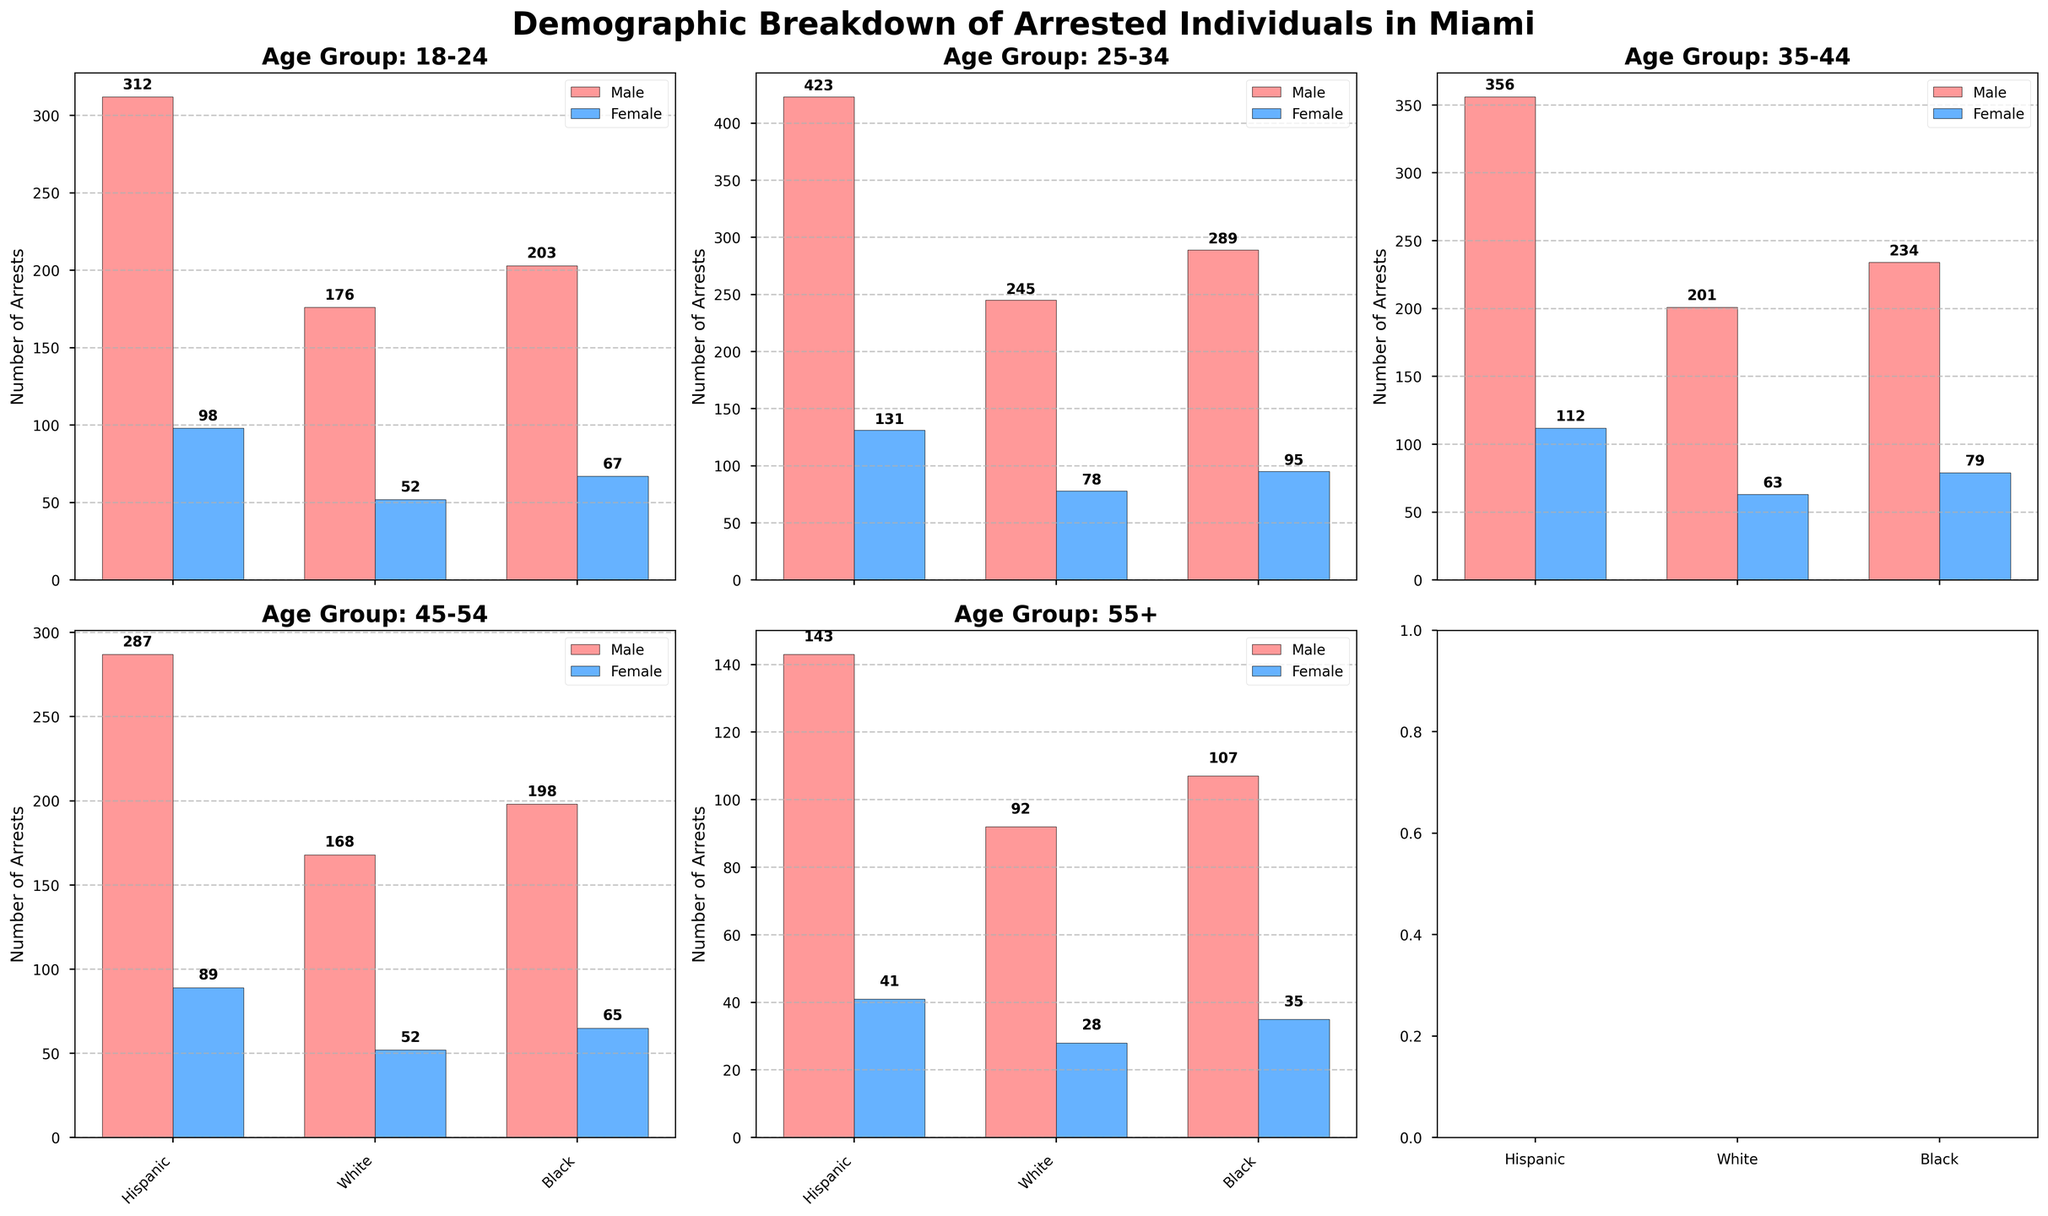What's the title of the figure? The title is usually located at the top of the figure and summarizes the main topic. Here, the title "Demographic Breakdown of Arrested Individuals in Miami" directly tells us what the figure is about.
Answer: Demographic Breakdown of Arrested Individuals in Miami How many age groups are presented in the figure? The number of subplots corresponds to the number of age groups, each with its own title indicating the age range. Counting the unique age group titles, we find five age groups.
Answer: 5 Which age group has the highest number of male arrests for Hispanic individuals? By examining the bars for male Hispanic arrests across all age group subplots, we observe that the '25-34' age group has the tallest bar, indicating the highest value.
Answer: 25-34 In the '45-54' age group, which gender has higher arrests for Black individuals? The heights of the bars in the '45-54' subplot for Black individuals show that males have taller bars compared to females.
Answer: Male Compare the number of arrests between Hispanic females and Black females in the '35-44' age group. Which is higher and by how much? Looking at the '35-44' subplot, the bar for Hispanic females is 112 and for Black females is 79. The difference is found by subtracting 79 from 112.
Answer: Hispanic, by 33 Identify the ethnic group with the lowest number of arrests in the '18-24' age group for both genders combined. Adding the arrests for both genders in each ethnic group in '18-24', the totals are: Hispanic (312 + 98 = 410), White (176 + 52 = 228), Black (203 + 67 = 270). Thus, White has the lowest combined arrests.
Answer: White For the age group '55+', which ethnic group has the greater gender gap in arrests, and what is the difference? For '55+', calculate the gender difference for each ethnic group: Hispanic (143 - 41 = 102), White (92 - 28 = 64), Black (107 - 35 = 72). Hispanic has the largest gender difference.
Answer: Hispanic, 102 Summarize the trend of male arrests across all age groups for White individuals. Observing the white male bars across each subplot, the counts start high at '18-24' with 176, increase to 245 in '25-34', then slightly decrease to 201 in '35-44', drop to 168 in '45-54', and further decrease to 92 in '55+'.
Answer: Decreasing Which ethnic group has the most consistent number of female arrests across all age groups? For each ethnic group, the female arrest values are as follows: Hispanic (98, 131, 112, 89, 41), White (52, 78, 63, 52, 28), Black (67, 95, 79, 65, 35). The Hispanic female arrests show the least variation, thus the most consistent.
Answer: Hispanic In the '25-34' age group, by how many arrests do Black males outnumber Hispanic females? In '25-34', Black males have 289 arrests, and Hispanic females have 131 arrests. Subtract 131 from 289 to find the difference.
Answer: 158 